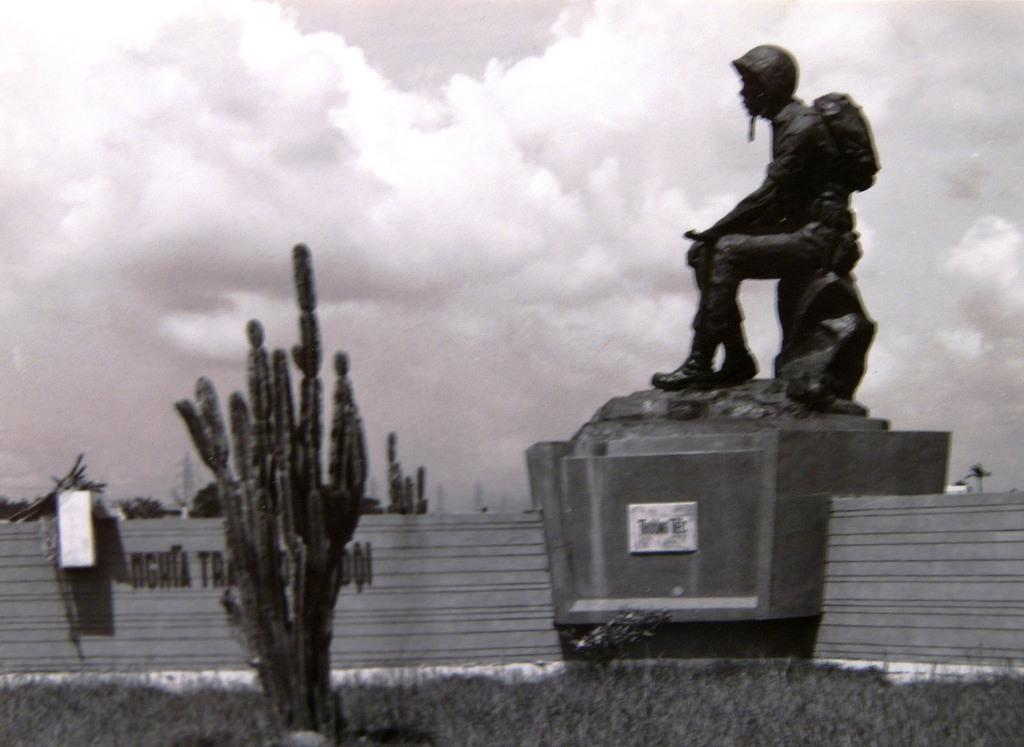What is the main subject of the image? There is a sculpture in the image. What other elements can be seen in the image? There is a plant, grass, a wall, and the sky visible in the image. Can you describe the sky in the image? The sky is visible in the background of the image, and there are clouds in the sky. How many children are playing with the pipe in the image? There are no children or pipes present in the image. 